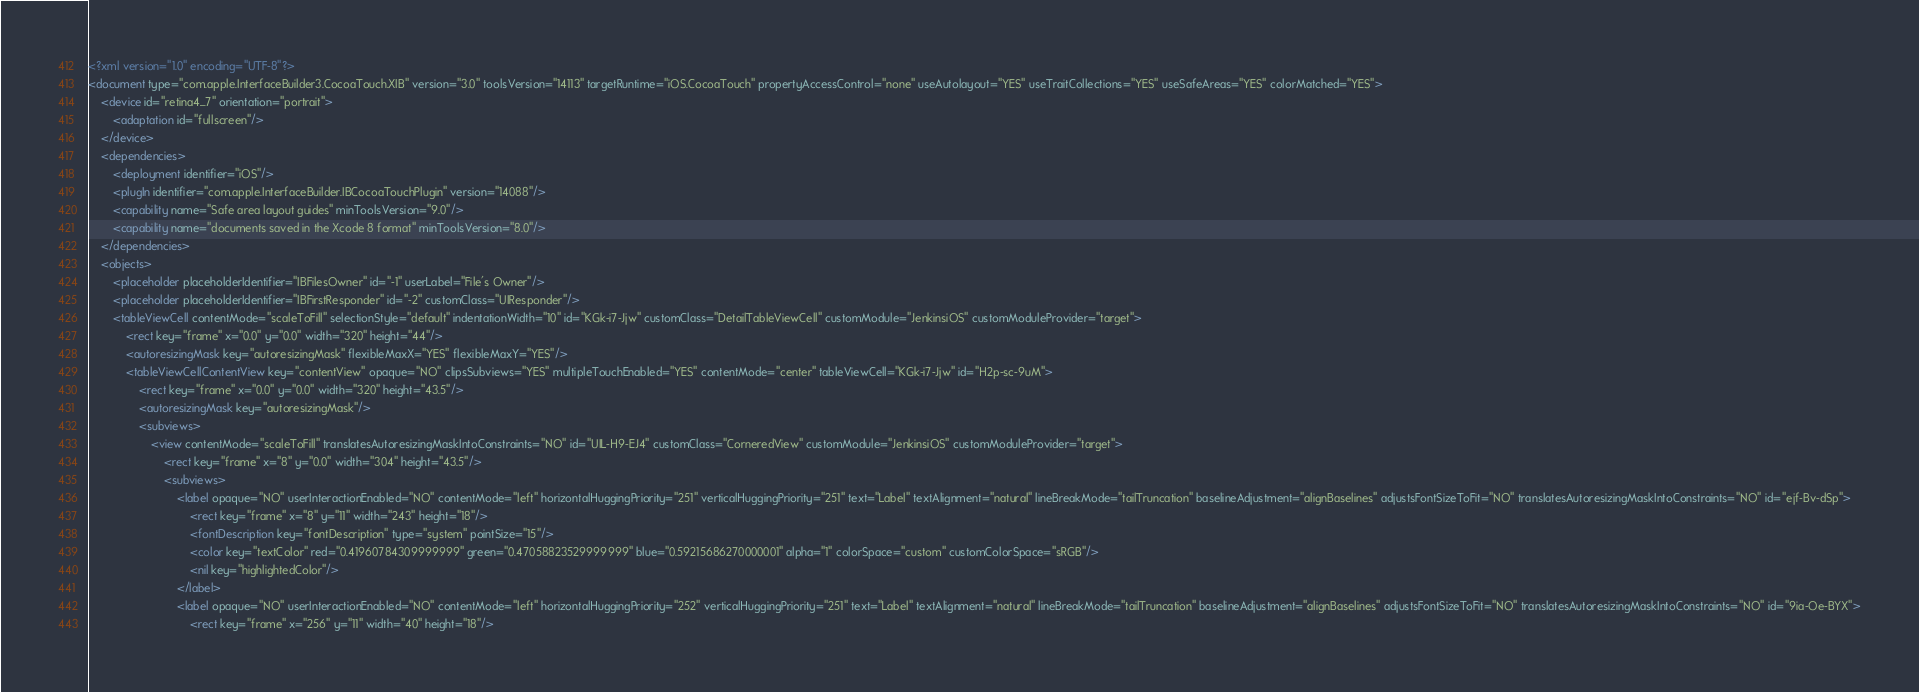Convert code to text. <code><loc_0><loc_0><loc_500><loc_500><_XML_><?xml version="1.0" encoding="UTF-8"?>
<document type="com.apple.InterfaceBuilder3.CocoaTouch.XIB" version="3.0" toolsVersion="14113" targetRuntime="iOS.CocoaTouch" propertyAccessControl="none" useAutolayout="YES" useTraitCollections="YES" useSafeAreas="YES" colorMatched="YES">
    <device id="retina4_7" orientation="portrait">
        <adaptation id="fullscreen"/>
    </device>
    <dependencies>
        <deployment identifier="iOS"/>
        <plugIn identifier="com.apple.InterfaceBuilder.IBCocoaTouchPlugin" version="14088"/>
        <capability name="Safe area layout guides" minToolsVersion="9.0"/>
        <capability name="documents saved in the Xcode 8 format" minToolsVersion="8.0"/>
    </dependencies>
    <objects>
        <placeholder placeholderIdentifier="IBFilesOwner" id="-1" userLabel="File's Owner"/>
        <placeholder placeholderIdentifier="IBFirstResponder" id="-2" customClass="UIResponder"/>
        <tableViewCell contentMode="scaleToFill" selectionStyle="default" indentationWidth="10" id="KGk-i7-Jjw" customClass="DetailTableViewCell" customModule="JenkinsiOS" customModuleProvider="target">
            <rect key="frame" x="0.0" y="0.0" width="320" height="44"/>
            <autoresizingMask key="autoresizingMask" flexibleMaxX="YES" flexibleMaxY="YES"/>
            <tableViewCellContentView key="contentView" opaque="NO" clipsSubviews="YES" multipleTouchEnabled="YES" contentMode="center" tableViewCell="KGk-i7-Jjw" id="H2p-sc-9uM">
                <rect key="frame" x="0.0" y="0.0" width="320" height="43.5"/>
                <autoresizingMask key="autoresizingMask"/>
                <subviews>
                    <view contentMode="scaleToFill" translatesAutoresizingMaskIntoConstraints="NO" id="UIL-H9-EJ4" customClass="CorneredView" customModule="JenkinsiOS" customModuleProvider="target">
                        <rect key="frame" x="8" y="0.0" width="304" height="43.5"/>
                        <subviews>
                            <label opaque="NO" userInteractionEnabled="NO" contentMode="left" horizontalHuggingPriority="251" verticalHuggingPriority="251" text="Label" textAlignment="natural" lineBreakMode="tailTruncation" baselineAdjustment="alignBaselines" adjustsFontSizeToFit="NO" translatesAutoresizingMaskIntoConstraints="NO" id="ejf-Bv-dSp">
                                <rect key="frame" x="8" y="11" width="243" height="18"/>
                                <fontDescription key="fontDescription" type="system" pointSize="15"/>
                                <color key="textColor" red="0.41960784309999999" green="0.47058823529999999" blue="0.59215686270000001" alpha="1" colorSpace="custom" customColorSpace="sRGB"/>
                                <nil key="highlightedColor"/>
                            </label>
                            <label opaque="NO" userInteractionEnabled="NO" contentMode="left" horizontalHuggingPriority="252" verticalHuggingPriority="251" text="Label" textAlignment="natural" lineBreakMode="tailTruncation" baselineAdjustment="alignBaselines" adjustsFontSizeToFit="NO" translatesAutoresizingMaskIntoConstraints="NO" id="9ia-Oe-BYX">
                                <rect key="frame" x="256" y="11" width="40" height="18"/></code> 